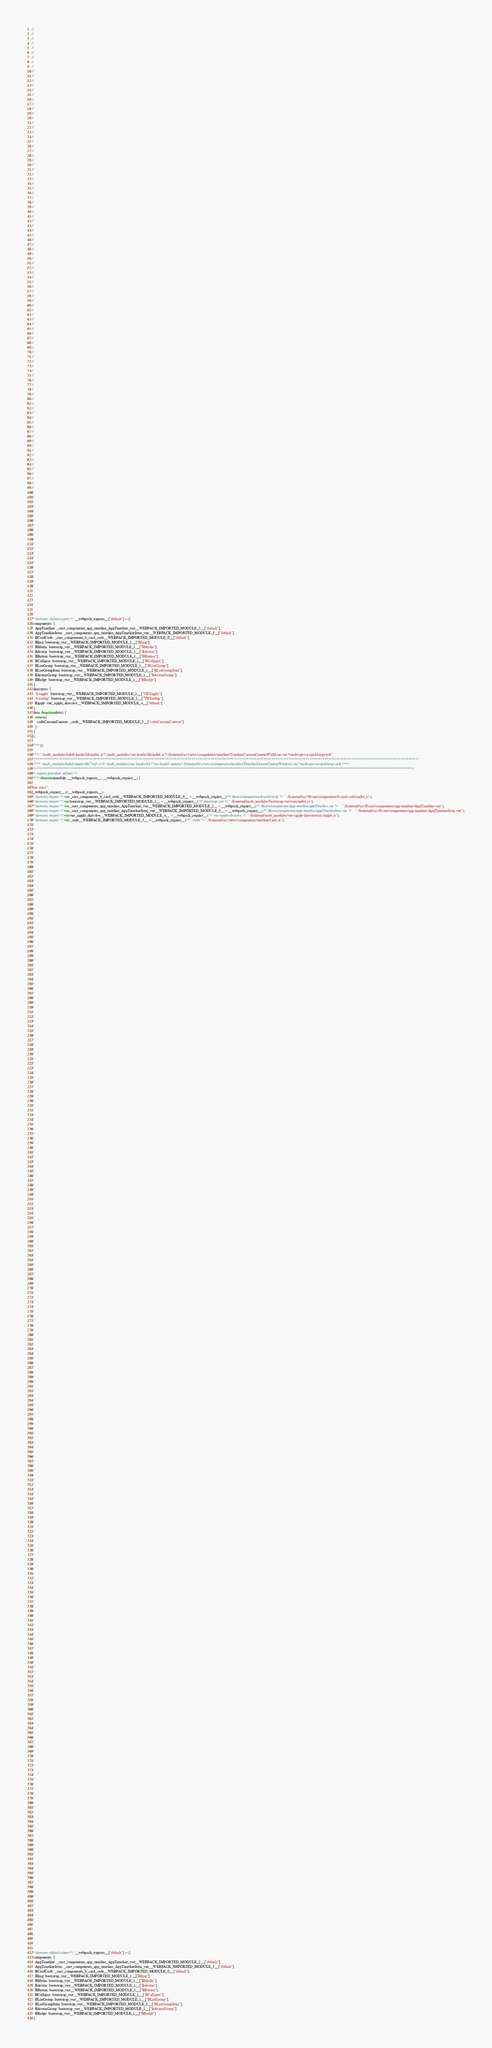<code> <loc_0><loc_0><loc_500><loc_500><_JavaScript_>//
//
//
//
//
//
//
//
//
//
//
//
//
//
//
//
//
//
//
//
//
//
//
//
//
//
//
//
//
//
//
//
//
//
//
//
//
//
//
//
//
//
//
//
//
//
//
//
//
//
//
//
//
//
//
//
//
//
//
//
//
//
//
//
//
//
//
//
//
//
//
//
//
//
//
//
//
//
//
//
//
//
//
//
//
//
//
//
//
//
//
//
//
//
//
//
//
//
//
//
//
//
//
//
//
//
//
//
//
//
//
//
//
//
//
//
//
//
//
//






/* harmony default export */ __webpack_exports__["default"] = ({
  components: {
    AppTimeline: _core_components_app_timeline_AppTimeline_vue__WEBPACK_IMPORTED_MODULE_2__["default"],
    AppTimelineItem: _core_components_app_timeline_AppTimelineItem_vue__WEBPACK_IMPORTED_MODULE_3__["default"],
    BCardCode: _core_components_b_card_code__WEBPACK_IMPORTED_MODULE_0__["default"],
    BImg: bootstrap_vue__WEBPACK_IMPORTED_MODULE_1__["BImg"],
    BMedia: bootstrap_vue__WEBPACK_IMPORTED_MODULE_1__["BMedia"],
    BAvatar: bootstrap_vue__WEBPACK_IMPORTED_MODULE_1__["BAvatar"],
    BButton: bootstrap_vue__WEBPACK_IMPORTED_MODULE_1__["BButton"],
    BCollapse: bootstrap_vue__WEBPACK_IMPORTED_MODULE_1__["BCollapse"],
    BListGroup: bootstrap_vue__WEBPACK_IMPORTED_MODULE_1__["BListGroup"],
    BListGroupItem: bootstrap_vue__WEBPACK_IMPORTED_MODULE_1__["BListGroupItem"],
    BAvatarGroup: bootstrap_vue__WEBPACK_IMPORTED_MODULE_1__["BAvatarGroup"],
    BBadge: bootstrap_vue__WEBPACK_IMPORTED_MODULE_1__["BBadge"]
  },
  directives: {
    'b-toggle': bootstrap_vue__WEBPACK_IMPORTED_MODULE_1__["VBToggle"],
    'b-tooltip': bootstrap_vue__WEBPACK_IMPORTED_MODULE_1__["VBTooltip"],
    Ripple: vue_ripple_directive__WEBPACK_IMPORTED_MODULE_4__["default"]
  },
  data: function data() {
    return {
      codeCustomContent: _code__WEBPACK_IMPORTED_MODULE_5__["codeCustomContent"]
    };
  }
});

/***/ }),

/***/ "./node_modules/babel-loader/lib/index.js?!./node_modules/vue-loader/lib/index.js?!./frontend/src/views/components/timeline/TimelineCustomContentWithIcon.vue?vue&type=script&lang=js&":
/*!*******************************************************************************************************************************************************************************************************!*\
  !*** ./node_modules/babel-loader/lib??ref--4-0!./node_modules/vue-loader/lib??vue-loader-options!./frontend/src/views/components/timeline/TimelineCustomContentWithIcon.vue?vue&type=script&lang=js& ***!
  \*******************************************************************************************************************************************************************************************************/
/*! exports provided: default */
/***/ (function(module, __webpack_exports__, __webpack_require__) {

"use strict";
__webpack_require__.r(__webpack_exports__);
/* harmony import */ var _core_components_b_card_code__WEBPACK_IMPORTED_MODULE_0__ = __webpack_require__(/*! @core/components/b-card-code */ "./frontend/src/@core/components/b-card-code/index.js");
/* harmony import */ var bootstrap_vue__WEBPACK_IMPORTED_MODULE_1__ = __webpack_require__(/*! bootstrap-vue */ "./frontend/node_modules/bootstrap-vue/esm/index.js");
/* harmony import */ var _core_components_app_timeline_AppTimeline_vue__WEBPACK_IMPORTED_MODULE_2__ = __webpack_require__(/*! @core/components/app-timeline/AppTimeline.vue */ "./frontend/src/@core/components/app-timeline/AppTimeline.vue");
/* harmony import */ var _core_components_app_timeline_AppTimelineItem_vue__WEBPACK_IMPORTED_MODULE_3__ = __webpack_require__(/*! @core/components/app-timeline/AppTimelineItem.vue */ "./frontend/src/@core/components/app-timeline/AppTimelineItem.vue");
/* harmony import */ var vue_ripple_directive__WEBPACK_IMPORTED_MODULE_4__ = __webpack_require__(/*! vue-ripple-directive */ "./frontend/node_modules/vue-ripple-directive/src/ripple.js");
/* harmony import */ var _code__WEBPACK_IMPORTED_MODULE_5__ = __webpack_require__(/*! ./code */ "./frontend/src/views/components/timeline/code.js");
//
//
//
//
//
//
//
//
//
//
//
//
//
//
//
//
//
//
//
//
//
//
//
//
//
//
//
//
//
//
//
//
//
//
//
//
//
//
//
//
//
//
//
//
//
//
//
//
//
//
//
//
//
//
//
//
//
//
//
//
//
//
//
//
//
//
//
//
//
//
//
//
//
//
//
//
//
//
//
//
//
//
//
//
//
//
//
//
//
//
//
//
//
//
//
//
//
//
//
//
//
//
//
//
//
//
//
//
//
//
//
//
//
//
//
//
//
//
//
//
//
//
//
//
//
//
//
//
//
//
//
//
//
//
//
//
//
//
//
//
//
//
//
//
//
//
//
//
//
//
//
//
//
//
//
//
//
//
//
//
//
//
//
//
//
//
//
//
//
//
//
//
//
//
//
//
//
//
//
//
//
//
//
//
//
//
//
//
//
//
//
//
//
//
//
//
//
//
//
//
//
//
//
//
//
//
//
//
//
//
//
//
//
//
//
//
//
//
//
//
//
//
//
//
//
//
//
//
//
//
//
//
//
//
//






/* harmony default export */ __webpack_exports__["default"] = ({
  components: {
    AppTimeline: _core_components_app_timeline_AppTimeline_vue__WEBPACK_IMPORTED_MODULE_2__["default"],
    AppTimelineItem: _core_components_app_timeline_AppTimelineItem_vue__WEBPACK_IMPORTED_MODULE_3__["default"],
    BCardCode: _core_components_b_card_code__WEBPACK_IMPORTED_MODULE_0__["default"],
    BImg: bootstrap_vue__WEBPACK_IMPORTED_MODULE_1__["BImg"],
    BMedia: bootstrap_vue__WEBPACK_IMPORTED_MODULE_1__["BMedia"],
    BAvatar: bootstrap_vue__WEBPACK_IMPORTED_MODULE_1__["BAvatar"],
    BButton: bootstrap_vue__WEBPACK_IMPORTED_MODULE_1__["BButton"],
    BCollapse: bootstrap_vue__WEBPACK_IMPORTED_MODULE_1__["BCollapse"],
    BListGroup: bootstrap_vue__WEBPACK_IMPORTED_MODULE_1__["BListGroup"],
    BListGroupItem: bootstrap_vue__WEBPACK_IMPORTED_MODULE_1__["BListGroupItem"],
    BAvatarGroup: bootstrap_vue__WEBPACK_IMPORTED_MODULE_1__["BAvatarGroup"],
    BBadge: bootstrap_vue__WEBPACK_IMPORTED_MODULE_1__["BBadge"]
  },</code> 